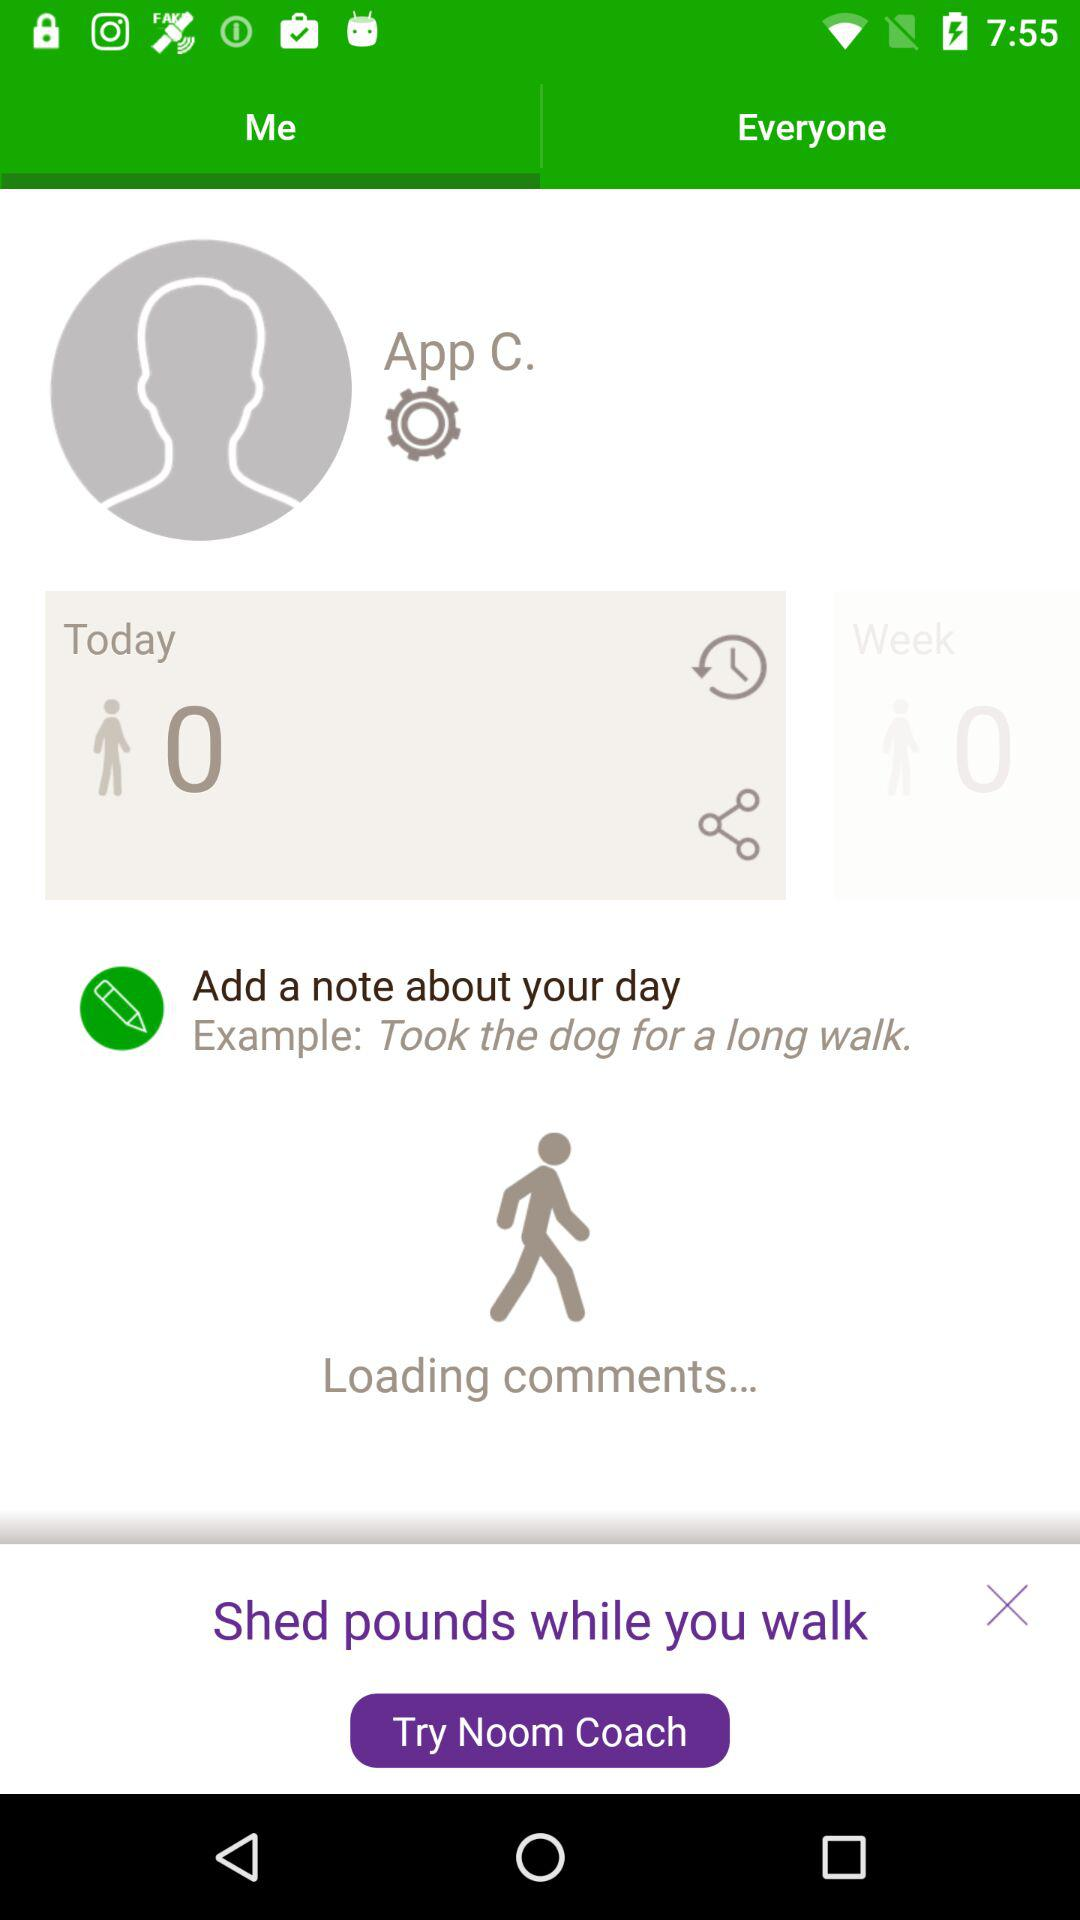How many steps did I take today?
Answer the question using a single word or phrase. 0 